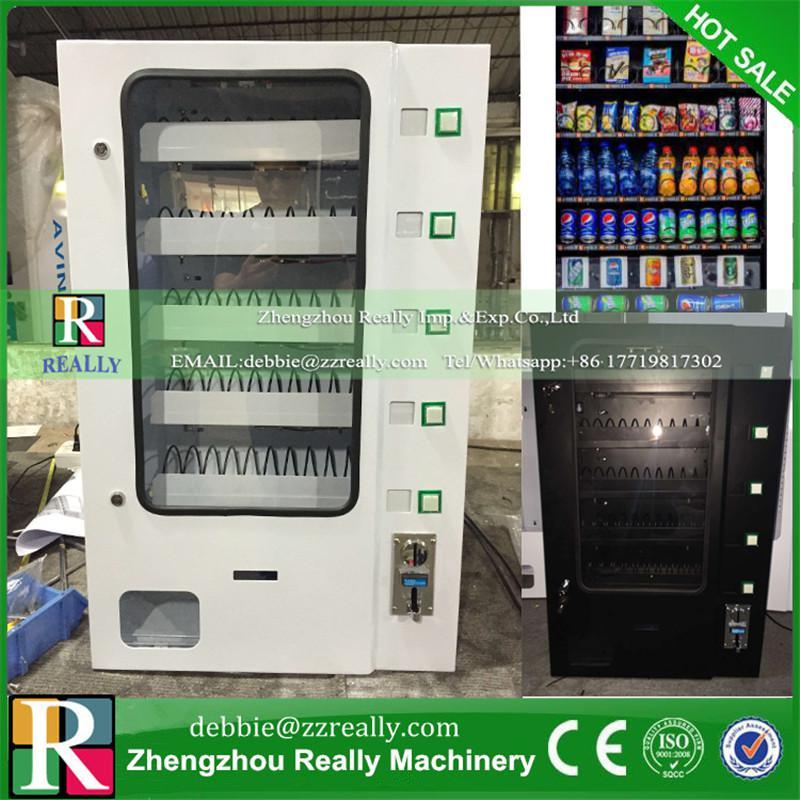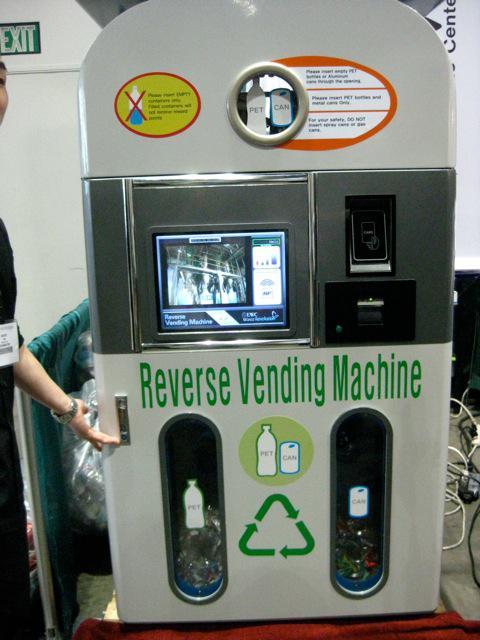The first image is the image on the left, the second image is the image on the right. Considering the images on both sides, is "There are at least three vending machines that have food or drinks." valid? Answer yes or no. No. 